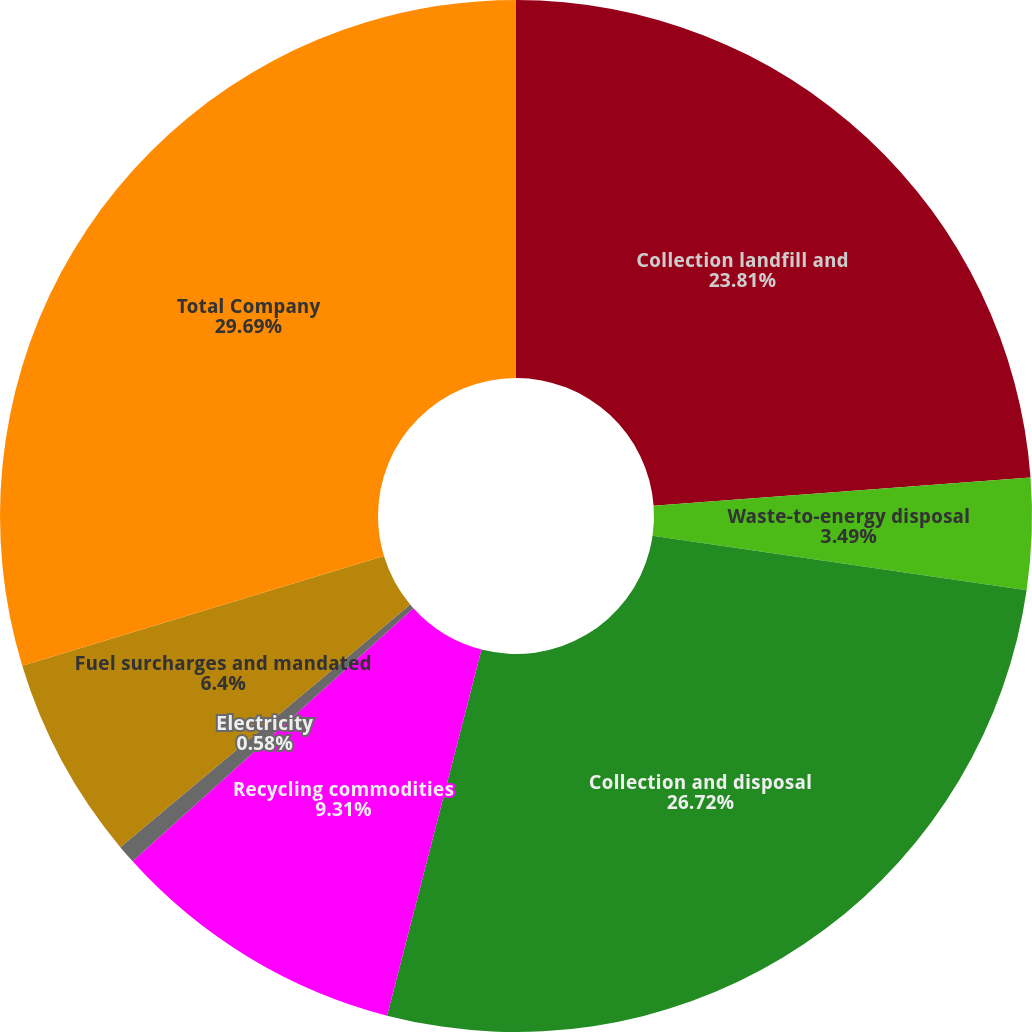Convert chart. <chart><loc_0><loc_0><loc_500><loc_500><pie_chart><fcel>Collection landfill and<fcel>Waste-to-energy disposal<fcel>Collection and disposal<fcel>Recycling commodities<fcel>Electricity<fcel>Fuel surcharges and mandated<fcel>Total Company<nl><fcel>23.81%<fcel>3.49%<fcel>26.72%<fcel>9.31%<fcel>0.58%<fcel>6.4%<fcel>29.69%<nl></chart> 